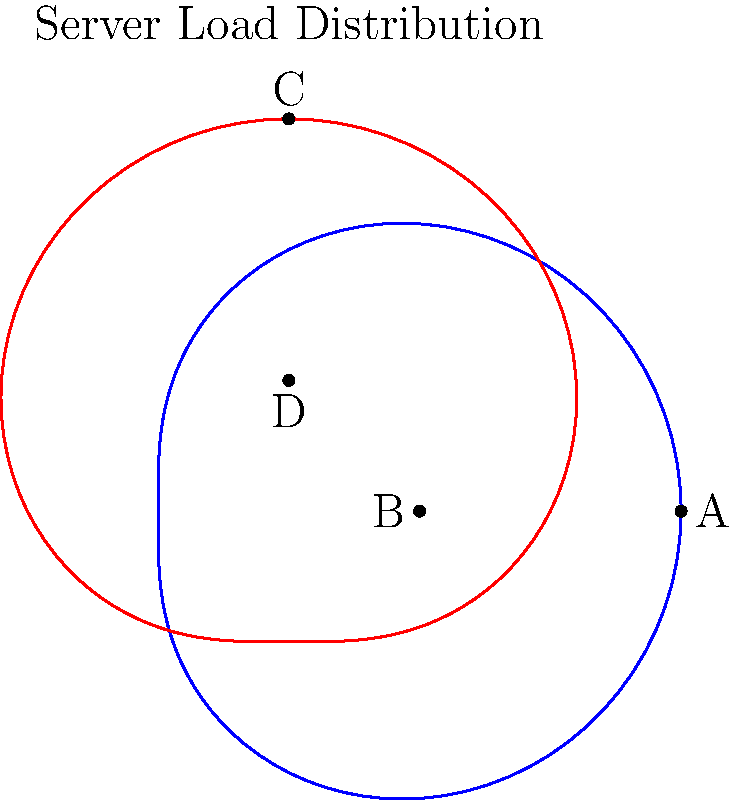In the polar coordinate system shown above, two curves represent server load distribution patterns. The blue curve is given by $r = 2 + \cos(\theta)$, and the red curve by $r = 2 + \sin(\theta)$. Which point(s) represent the maximum load for each distribution, and what strategy would you recommend to optimize the overall system performance? To solve this problem, let's follow these steps:

1. Analyze the blue curve $(r = 2 + \cos(\theta))$:
   - The maximum value of $\cos(\theta)$ is 1, occurring at $\theta = 0$ and $2\pi$.
   - Therefore, the maximum $r$ value is 3, corresponding to point A $(3,0)$.

2. Analyze the red curve $(r = 2 + \sin(\theta))$:
   - The maximum value of $\sin(\theta)$ is 1, occurring at $\theta = \frac{\pi}{2}$.
   - Therefore, the maximum $r$ value is 3, corresponding to point C $(0,3)$.

3. Interpret the results:
   - For the blue curve, the maximum load occurs at point A, representing peak traffic from the east.
   - For the red curve, the maximum load occurs at point C, representing peak traffic from the north.

4. Optimization strategy:
   - Implement load balancing between eastern and northern server clusters.
   - Increase server capacity or redistribute resources to handle peak loads at points A and C.
   - Consider using Content Delivery Networks (CDNs) to offload traffic in these directions.
   - Implement caching mechanisms to reduce server load during peak times.
   - Set up monitoring and alerting systems for when load approaches these maximum points.
   - Consider implementing auto-scaling solutions to dynamically adjust resources based on load patterns.

5. Overall system performance:
   - By addressing both peak load scenarios (A and C), the system can maintain optimal performance under varying traffic conditions.
   - The complementary nature of the two distributions allows for efficient resource allocation and load distribution across the network.
Answer: A (east) and C (north); implement load balancing, increase capacity at A and C, use CDNs, caching, monitoring, and auto-scaling. 